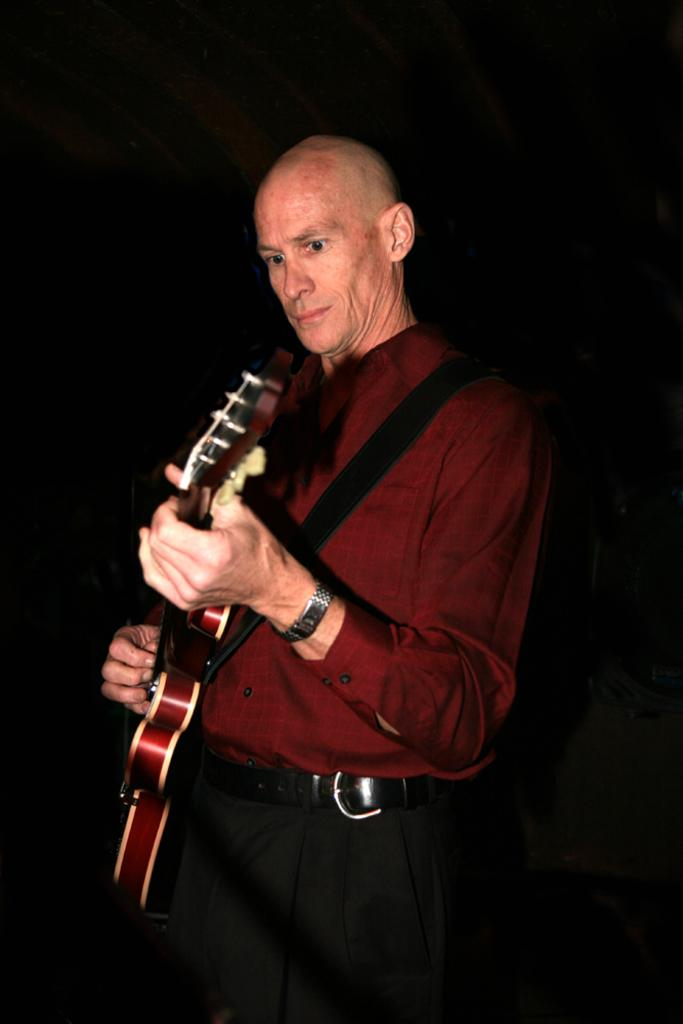What is the person in the image doing? The person is standing. What object is the person holding in the image? The person is holding a guitar. What accessory is the person wearing on their wrist? The person is wearing a watch. What clothing item is the person wearing around their waist? The person is wearing a belt. What type of noise can be heard coming from the dinosaurs in the image? There are no dinosaurs present in the image, so no noise can be heard from them. 